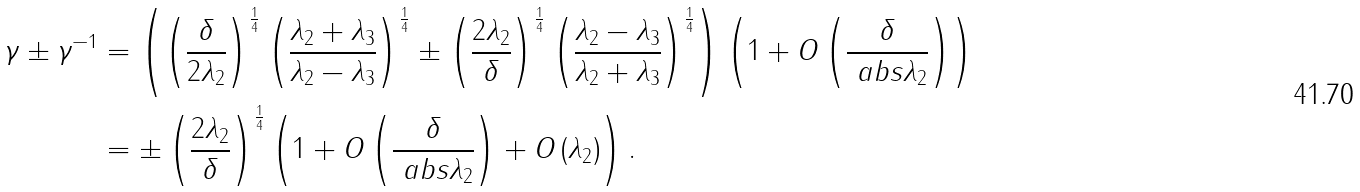<formula> <loc_0><loc_0><loc_500><loc_500>\gamma \pm \gamma ^ { - 1 } & = \left ( \left ( \frac { \delta } { 2 \lambda _ { 2 } } \right ) ^ { \frac { 1 } { 4 } } \left ( \frac { \lambda _ { 2 } + \lambda _ { 3 } } { \lambda _ { 2 } - \lambda _ { 3 } } \right ) ^ { \frac { 1 } { 4 } } \pm \left ( \frac { 2 \lambda _ { 2 } } { \delta } \right ) ^ { \frac { 1 } { 4 } } \left ( \frac { \lambda _ { 2 } - \lambda _ { 3 } } { \lambda _ { 2 } + \lambda _ { 3 } } \right ) ^ { \frac { 1 } { 4 } } \right ) \left ( 1 + O \left ( \frac { \delta } { \ a b s { \lambda _ { 2 } } } \right ) \right ) \\ & = \pm \left ( \frac { 2 \lambda _ { 2 } } { \delta } \right ) ^ { \frac { 1 } { 4 } } \left ( 1 + O \left ( \frac { \delta } { \ a b s { \lambda _ { 2 } } } \right ) + O \left ( \lambda _ { 2 } \right ) \right ) .</formula> 